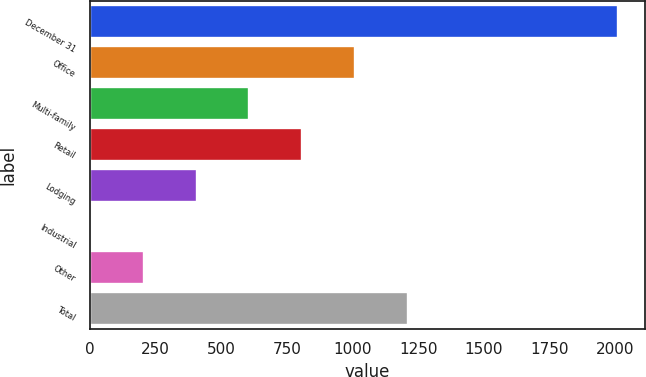<chart> <loc_0><loc_0><loc_500><loc_500><bar_chart><fcel>December 31<fcel>Office<fcel>Multi-family<fcel>Retail<fcel>Lodging<fcel>Industrial<fcel>Other<fcel>Total<nl><fcel>2012<fcel>1009<fcel>607.8<fcel>808.4<fcel>407.2<fcel>6<fcel>206.6<fcel>1209.6<nl></chart> 